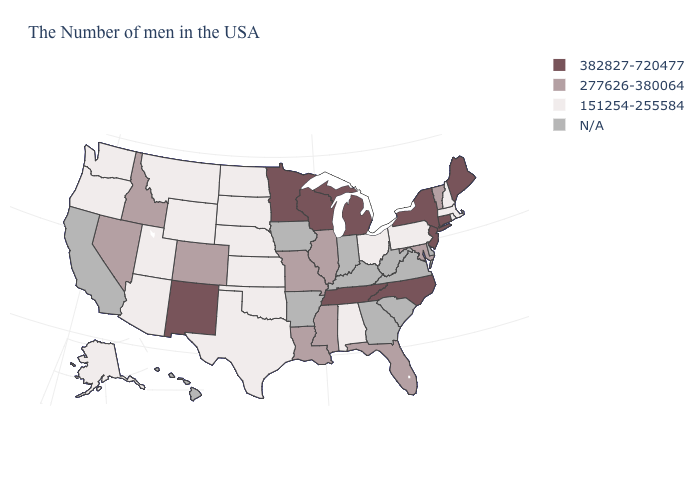Is the legend a continuous bar?
Keep it brief. No. What is the value of Delaware?
Quick response, please. N/A. What is the value of Virginia?
Quick response, please. N/A. What is the lowest value in the MidWest?
Short answer required. 151254-255584. What is the lowest value in the USA?
Concise answer only. 151254-255584. What is the value of Georgia?
Quick response, please. N/A. Which states hav the highest value in the South?
Keep it brief. North Carolina, Tennessee. Name the states that have a value in the range 382827-720477?
Short answer required. Maine, Connecticut, New York, New Jersey, North Carolina, Michigan, Tennessee, Wisconsin, Minnesota, New Mexico. Which states hav the highest value in the MidWest?
Concise answer only. Michigan, Wisconsin, Minnesota. Does Ohio have the lowest value in the MidWest?
Answer briefly. Yes. Among the states that border Oklahoma , does New Mexico have the highest value?
Short answer required. Yes. What is the value of Maryland?
Give a very brief answer. 277626-380064. What is the highest value in states that border Idaho?
Short answer required. 277626-380064. Among the states that border California , which have the highest value?
Answer briefly. Nevada. 